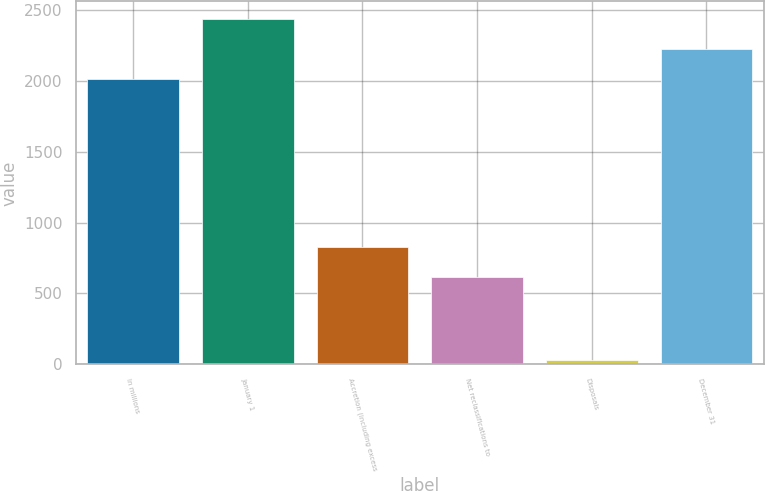Convert chart. <chart><loc_0><loc_0><loc_500><loc_500><bar_chart><fcel>In millions<fcel>January 1<fcel>Accretion (including excess<fcel>Net reclassifications to<fcel>Disposals<fcel>December 31<nl><fcel>2013<fcel>2440.4<fcel>826.7<fcel>613<fcel>29<fcel>2226.7<nl></chart> 